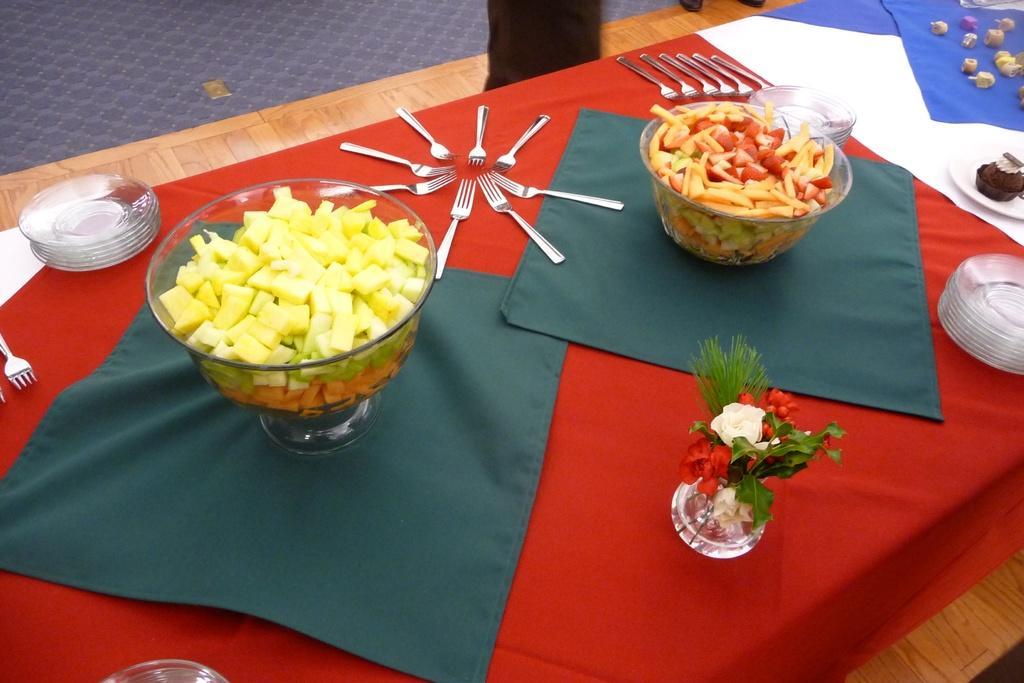Could you give a brief overview of what you see in this image? On this table there is a cloth, flowers in a vase, bowls, forks, plates and food.  